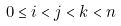Convert formula to latex. <formula><loc_0><loc_0><loc_500><loc_500>0 \leq i < j < k < n</formula> 